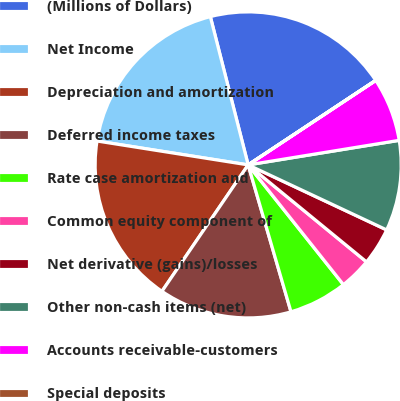Convert chart. <chart><loc_0><loc_0><loc_500><loc_500><pie_chart><fcel>(Millions of Dollars)<fcel>Net Income<fcel>Depreciation and amortization<fcel>Deferred income taxes<fcel>Rate case amortization and<fcel>Common equity component of<fcel>Net derivative (gains)/losses<fcel>Other non-cash items (net)<fcel>Accounts receivable-customers<fcel>Special deposits<nl><fcel>19.66%<fcel>18.53%<fcel>17.97%<fcel>14.04%<fcel>6.18%<fcel>3.38%<fcel>3.94%<fcel>9.55%<fcel>6.74%<fcel>0.01%<nl></chart> 